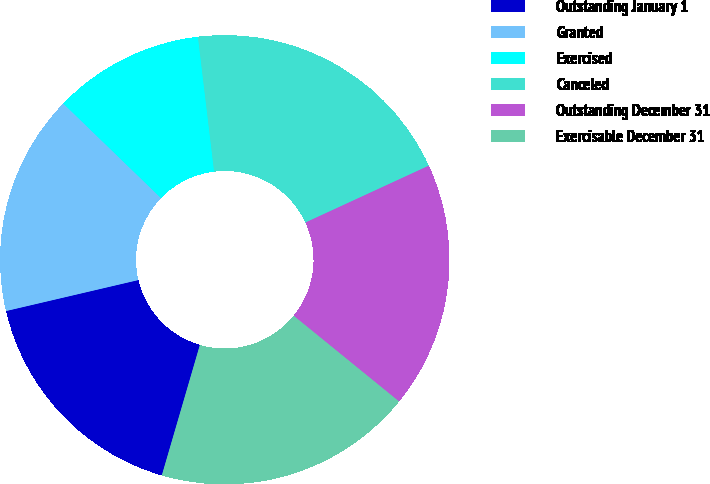Convert chart to OTSL. <chart><loc_0><loc_0><loc_500><loc_500><pie_chart><fcel>Outstanding January 1<fcel>Granted<fcel>Exercised<fcel>Canceled<fcel>Outstanding December 31<fcel>Exercisable December 31<nl><fcel>16.82%<fcel>15.9%<fcel>10.86%<fcel>20.03%<fcel>17.74%<fcel>18.65%<nl></chart> 